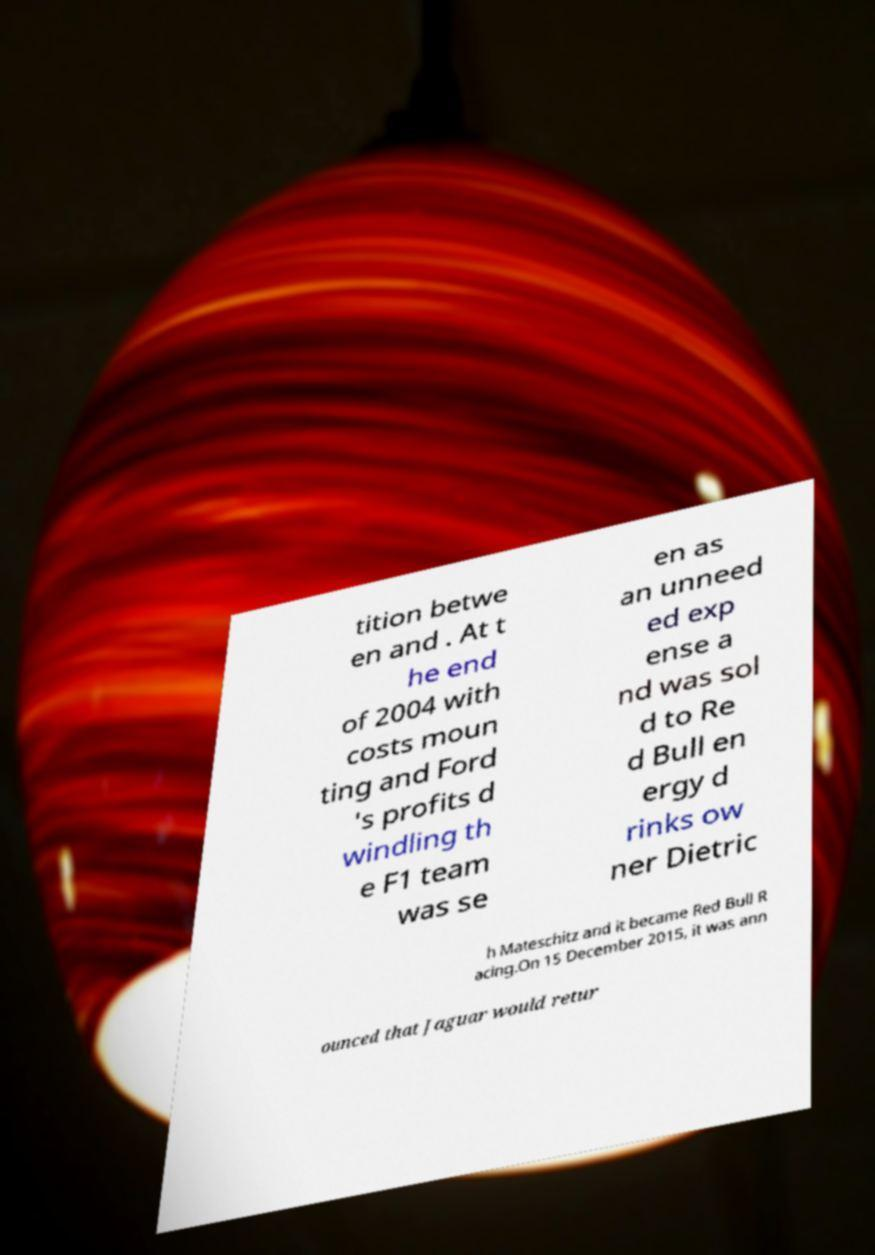Could you extract and type out the text from this image? tition betwe en and . At t he end of 2004 with costs moun ting and Ford 's profits d windling th e F1 team was se en as an unneed ed exp ense a nd was sol d to Re d Bull en ergy d rinks ow ner Dietric h Mateschitz and it became Red Bull R acing.On 15 December 2015, it was ann ounced that Jaguar would retur 